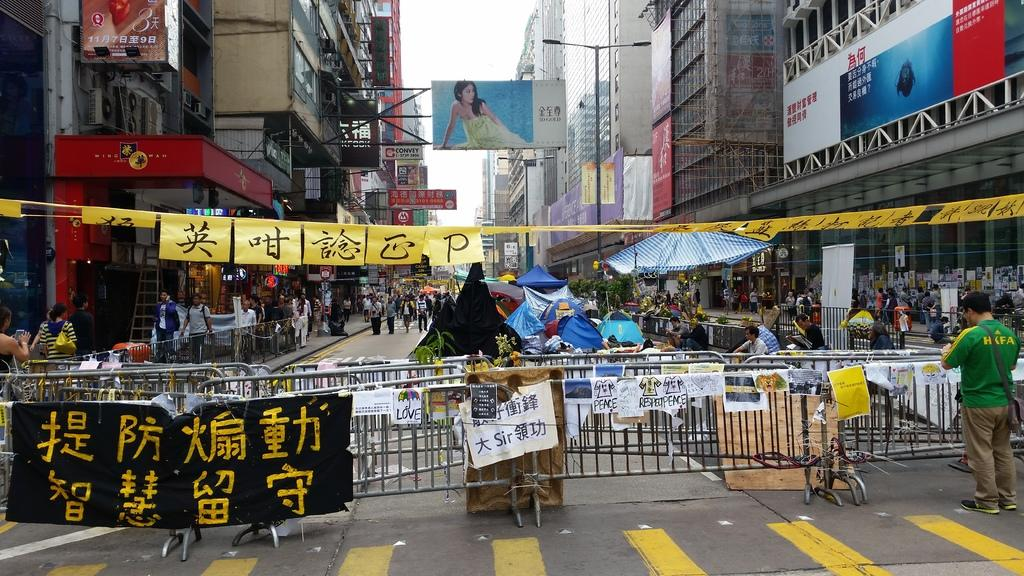Provide a one-sentence caption for the provided image. Man standing by barrier gate with a green shirt with HKFA in yellow letters on the back. 